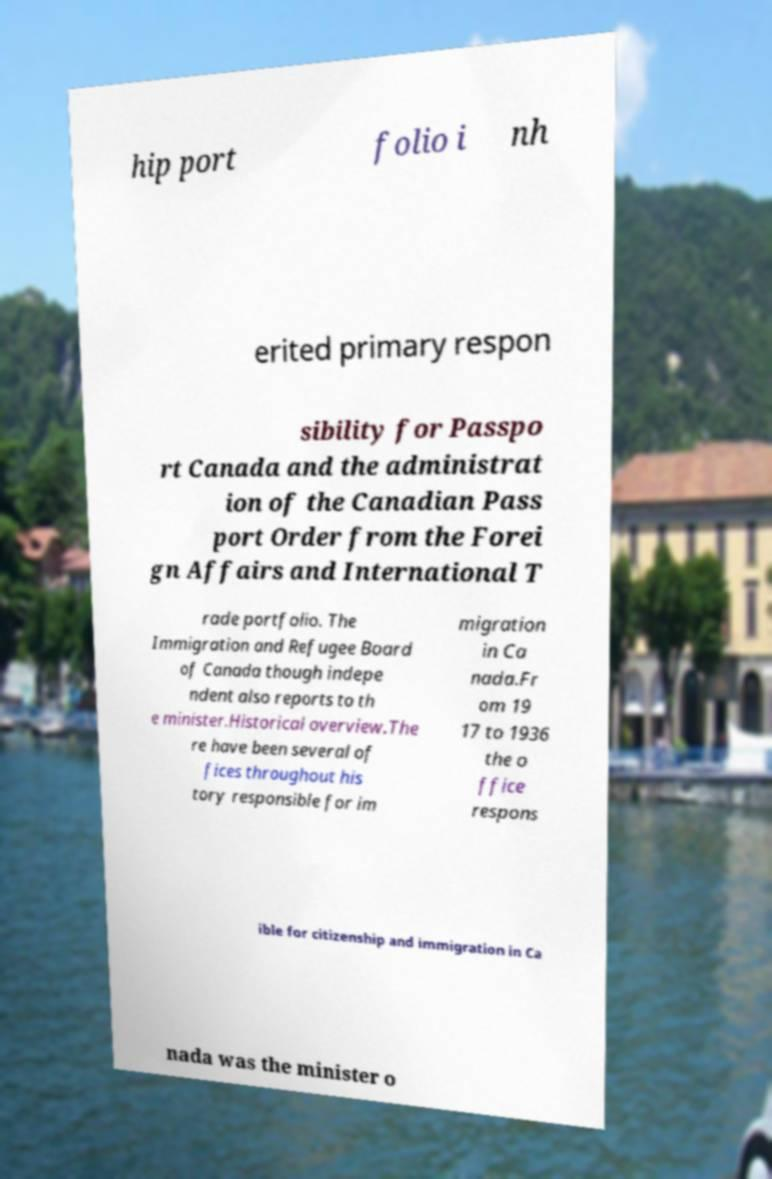Could you extract and type out the text from this image? hip port folio i nh erited primary respon sibility for Passpo rt Canada and the administrat ion of the Canadian Pass port Order from the Forei gn Affairs and International T rade portfolio. The Immigration and Refugee Board of Canada though indepe ndent also reports to th e minister.Historical overview.The re have been several of fices throughout his tory responsible for im migration in Ca nada.Fr om 19 17 to 1936 the o ffice respons ible for citizenship and immigration in Ca nada was the minister o 